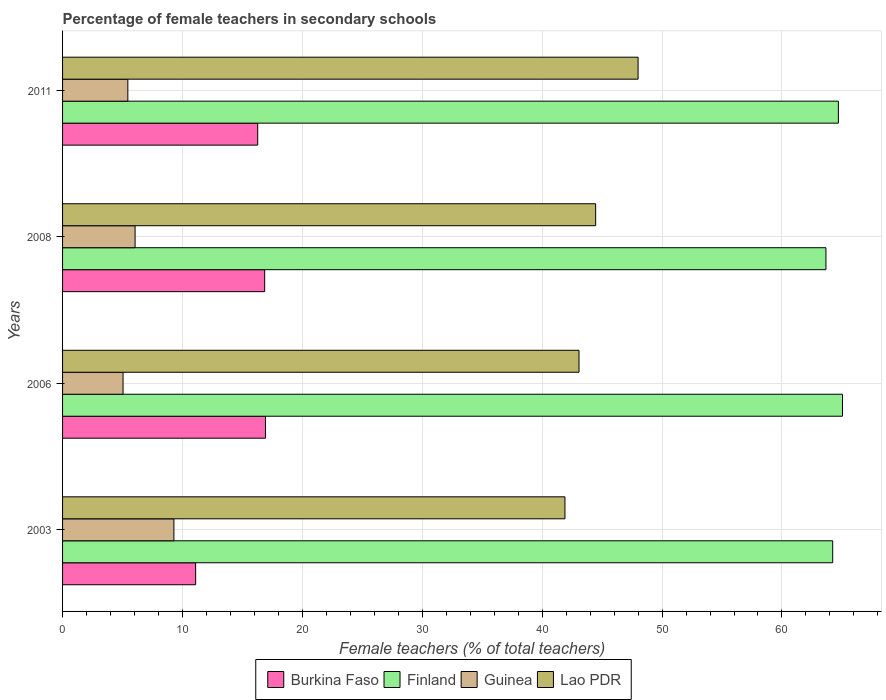How many groups of bars are there?
Your answer should be compact. 4. Are the number of bars per tick equal to the number of legend labels?
Offer a very short reply. Yes. How many bars are there on the 3rd tick from the top?
Offer a very short reply. 4. What is the percentage of female teachers in Burkina Faso in 2006?
Offer a terse response. 16.92. Across all years, what is the maximum percentage of female teachers in Burkina Faso?
Give a very brief answer. 16.92. Across all years, what is the minimum percentage of female teachers in Burkina Faso?
Your response must be concise. 11.1. In which year was the percentage of female teachers in Lao PDR maximum?
Offer a terse response. 2011. What is the total percentage of female teachers in Finland in the graph?
Give a very brief answer. 257.65. What is the difference between the percentage of female teachers in Guinea in 2008 and that in 2011?
Ensure brevity in your answer.  0.6. What is the difference between the percentage of female teachers in Burkina Faso in 2011 and the percentage of female teachers in Lao PDR in 2003?
Your response must be concise. -25.63. What is the average percentage of female teachers in Lao PDR per year?
Keep it short and to the point. 44.36. In the year 2003, what is the difference between the percentage of female teachers in Lao PDR and percentage of female teachers in Guinea?
Give a very brief answer. 32.61. What is the ratio of the percentage of female teachers in Lao PDR in 2006 to that in 2011?
Keep it short and to the point. 0.9. Is the percentage of female teachers in Burkina Faso in 2006 less than that in 2008?
Offer a very short reply. No. Is the difference between the percentage of female teachers in Lao PDR in 2003 and 2008 greater than the difference between the percentage of female teachers in Guinea in 2003 and 2008?
Give a very brief answer. No. What is the difference between the highest and the second highest percentage of female teachers in Guinea?
Ensure brevity in your answer.  3.24. What is the difference between the highest and the lowest percentage of female teachers in Finland?
Ensure brevity in your answer.  1.38. In how many years, is the percentage of female teachers in Finland greater than the average percentage of female teachers in Finland taken over all years?
Ensure brevity in your answer.  2. Is the sum of the percentage of female teachers in Finland in 2003 and 2008 greater than the maximum percentage of female teachers in Guinea across all years?
Provide a succinct answer. Yes. Is it the case that in every year, the sum of the percentage of female teachers in Guinea and percentage of female teachers in Burkina Faso is greater than the sum of percentage of female teachers in Lao PDR and percentage of female teachers in Finland?
Your response must be concise. Yes. What does the 2nd bar from the top in 2011 represents?
Ensure brevity in your answer.  Guinea. What does the 1st bar from the bottom in 2006 represents?
Provide a succinct answer. Burkina Faso. Is it the case that in every year, the sum of the percentage of female teachers in Burkina Faso and percentage of female teachers in Guinea is greater than the percentage of female teachers in Lao PDR?
Ensure brevity in your answer.  No. How many bars are there?
Give a very brief answer. 16. Are all the bars in the graph horizontal?
Keep it short and to the point. Yes. How many years are there in the graph?
Offer a terse response. 4. Are the values on the major ticks of X-axis written in scientific E-notation?
Provide a succinct answer. No. Does the graph contain any zero values?
Your response must be concise. No. Does the graph contain grids?
Keep it short and to the point. Yes. Where does the legend appear in the graph?
Offer a very short reply. Bottom center. What is the title of the graph?
Ensure brevity in your answer.  Percentage of female teachers in secondary schools. What is the label or title of the X-axis?
Provide a short and direct response. Female teachers (% of total teachers). What is the label or title of the Y-axis?
Keep it short and to the point. Years. What is the Female teachers (% of total teachers) in Burkina Faso in 2003?
Offer a very short reply. 11.1. What is the Female teachers (% of total teachers) of Finland in 2003?
Ensure brevity in your answer.  64.23. What is the Female teachers (% of total teachers) in Guinea in 2003?
Give a very brief answer. 9.29. What is the Female teachers (% of total teachers) in Lao PDR in 2003?
Provide a succinct answer. 41.9. What is the Female teachers (% of total teachers) in Burkina Faso in 2006?
Give a very brief answer. 16.92. What is the Female teachers (% of total teachers) in Finland in 2006?
Keep it short and to the point. 65.05. What is the Female teachers (% of total teachers) in Guinea in 2006?
Your answer should be compact. 5.05. What is the Female teachers (% of total teachers) of Lao PDR in 2006?
Keep it short and to the point. 43.07. What is the Female teachers (% of total teachers) of Burkina Faso in 2008?
Give a very brief answer. 16.86. What is the Female teachers (% of total teachers) in Finland in 2008?
Provide a succinct answer. 63.67. What is the Female teachers (% of total teachers) of Guinea in 2008?
Offer a terse response. 6.05. What is the Female teachers (% of total teachers) in Lao PDR in 2008?
Ensure brevity in your answer.  44.46. What is the Female teachers (% of total teachers) of Burkina Faso in 2011?
Provide a succinct answer. 16.27. What is the Female teachers (% of total teachers) in Finland in 2011?
Make the answer very short. 64.7. What is the Female teachers (% of total teachers) in Guinea in 2011?
Provide a succinct answer. 5.44. What is the Female teachers (% of total teachers) in Lao PDR in 2011?
Your response must be concise. 48. Across all years, what is the maximum Female teachers (% of total teachers) of Burkina Faso?
Make the answer very short. 16.92. Across all years, what is the maximum Female teachers (% of total teachers) in Finland?
Provide a succinct answer. 65.05. Across all years, what is the maximum Female teachers (% of total teachers) in Guinea?
Provide a succinct answer. 9.29. Across all years, what is the maximum Female teachers (% of total teachers) of Lao PDR?
Ensure brevity in your answer.  48. Across all years, what is the minimum Female teachers (% of total teachers) of Burkina Faso?
Offer a terse response. 11.1. Across all years, what is the minimum Female teachers (% of total teachers) in Finland?
Your answer should be compact. 63.67. Across all years, what is the minimum Female teachers (% of total teachers) of Guinea?
Provide a succinct answer. 5.05. Across all years, what is the minimum Female teachers (% of total teachers) in Lao PDR?
Your answer should be compact. 41.9. What is the total Female teachers (% of total teachers) in Burkina Faso in the graph?
Your answer should be compact. 61.15. What is the total Female teachers (% of total teachers) in Finland in the graph?
Your answer should be compact. 257.65. What is the total Female teachers (% of total teachers) of Guinea in the graph?
Give a very brief answer. 25.82. What is the total Female teachers (% of total teachers) in Lao PDR in the graph?
Make the answer very short. 177.43. What is the difference between the Female teachers (% of total teachers) of Burkina Faso in 2003 and that in 2006?
Provide a succinct answer. -5.82. What is the difference between the Female teachers (% of total teachers) of Finland in 2003 and that in 2006?
Offer a very short reply. -0.82. What is the difference between the Female teachers (% of total teachers) of Guinea in 2003 and that in 2006?
Provide a succinct answer. 4.24. What is the difference between the Female teachers (% of total teachers) in Lao PDR in 2003 and that in 2006?
Ensure brevity in your answer.  -1.17. What is the difference between the Female teachers (% of total teachers) of Burkina Faso in 2003 and that in 2008?
Offer a terse response. -5.76. What is the difference between the Female teachers (% of total teachers) of Finland in 2003 and that in 2008?
Offer a very short reply. 0.56. What is the difference between the Female teachers (% of total teachers) in Guinea in 2003 and that in 2008?
Your response must be concise. 3.24. What is the difference between the Female teachers (% of total teachers) of Lao PDR in 2003 and that in 2008?
Ensure brevity in your answer.  -2.56. What is the difference between the Female teachers (% of total teachers) of Burkina Faso in 2003 and that in 2011?
Make the answer very short. -5.17. What is the difference between the Female teachers (% of total teachers) of Finland in 2003 and that in 2011?
Provide a short and direct response. -0.47. What is the difference between the Female teachers (% of total teachers) in Guinea in 2003 and that in 2011?
Your answer should be compact. 3.84. What is the difference between the Female teachers (% of total teachers) of Lao PDR in 2003 and that in 2011?
Your answer should be compact. -6.1. What is the difference between the Female teachers (% of total teachers) of Burkina Faso in 2006 and that in 2008?
Ensure brevity in your answer.  0.07. What is the difference between the Female teachers (% of total teachers) of Finland in 2006 and that in 2008?
Your response must be concise. 1.38. What is the difference between the Female teachers (% of total teachers) in Guinea in 2006 and that in 2008?
Your response must be concise. -1. What is the difference between the Female teachers (% of total teachers) in Lao PDR in 2006 and that in 2008?
Make the answer very short. -1.39. What is the difference between the Female teachers (% of total teachers) in Burkina Faso in 2006 and that in 2011?
Your answer should be very brief. 0.65. What is the difference between the Female teachers (% of total teachers) in Finland in 2006 and that in 2011?
Your answer should be compact. 0.34. What is the difference between the Female teachers (% of total teachers) in Guinea in 2006 and that in 2011?
Your response must be concise. -0.4. What is the difference between the Female teachers (% of total teachers) of Lao PDR in 2006 and that in 2011?
Your response must be concise. -4.93. What is the difference between the Female teachers (% of total teachers) of Burkina Faso in 2008 and that in 2011?
Your answer should be compact. 0.58. What is the difference between the Female teachers (% of total teachers) of Finland in 2008 and that in 2011?
Give a very brief answer. -1.04. What is the difference between the Female teachers (% of total teachers) in Guinea in 2008 and that in 2011?
Provide a short and direct response. 0.6. What is the difference between the Female teachers (% of total teachers) of Lao PDR in 2008 and that in 2011?
Provide a succinct answer. -3.54. What is the difference between the Female teachers (% of total teachers) in Burkina Faso in 2003 and the Female teachers (% of total teachers) in Finland in 2006?
Keep it short and to the point. -53.95. What is the difference between the Female teachers (% of total teachers) in Burkina Faso in 2003 and the Female teachers (% of total teachers) in Guinea in 2006?
Offer a terse response. 6.05. What is the difference between the Female teachers (% of total teachers) in Burkina Faso in 2003 and the Female teachers (% of total teachers) in Lao PDR in 2006?
Your answer should be very brief. -31.97. What is the difference between the Female teachers (% of total teachers) in Finland in 2003 and the Female teachers (% of total teachers) in Guinea in 2006?
Give a very brief answer. 59.18. What is the difference between the Female teachers (% of total teachers) of Finland in 2003 and the Female teachers (% of total teachers) of Lao PDR in 2006?
Your response must be concise. 21.16. What is the difference between the Female teachers (% of total teachers) in Guinea in 2003 and the Female teachers (% of total teachers) in Lao PDR in 2006?
Provide a short and direct response. -33.79. What is the difference between the Female teachers (% of total teachers) in Burkina Faso in 2003 and the Female teachers (% of total teachers) in Finland in 2008?
Make the answer very short. -52.57. What is the difference between the Female teachers (% of total teachers) of Burkina Faso in 2003 and the Female teachers (% of total teachers) of Guinea in 2008?
Your answer should be compact. 5.05. What is the difference between the Female teachers (% of total teachers) of Burkina Faso in 2003 and the Female teachers (% of total teachers) of Lao PDR in 2008?
Your response must be concise. -33.36. What is the difference between the Female teachers (% of total teachers) in Finland in 2003 and the Female teachers (% of total teachers) in Guinea in 2008?
Keep it short and to the point. 58.18. What is the difference between the Female teachers (% of total teachers) of Finland in 2003 and the Female teachers (% of total teachers) of Lao PDR in 2008?
Offer a terse response. 19.77. What is the difference between the Female teachers (% of total teachers) of Guinea in 2003 and the Female teachers (% of total teachers) of Lao PDR in 2008?
Your answer should be very brief. -35.18. What is the difference between the Female teachers (% of total teachers) of Burkina Faso in 2003 and the Female teachers (% of total teachers) of Finland in 2011?
Your answer should be compact. -53.61. What is the difference between the Female teachers (% of total teachers) in Burkina Faso in 2003 and the Female teachers (% of total teachers) in Guinea in 2011?
Your response must be concise. 5.65. What is the difference between the Female teachers (% of total teachers) of Burkina Faso in 2003 and the Female teachers (% of total teachers) of Lao PDR in 2011?
Ensure brevity in your answer.  -36.9. What is the difference between the Female teachers (% of total teachers) in Finland in 2003 and the Female teachers (% of total teachers) in Guinea in 2011?
Your response must be concise. 58.79. What is the difference between the Female teachers (% of total teachers) of Finland in 2003 and the Female teachers (% of total teachers) of Lao PDR in 2011?
Your response must be concise. 16.23. What is the difference between the Female teachers (% of total teachers) in Guinea in 2003 and the Female teachers (% of total teachers) in Lao PDR in 2011?
Offer a terse response. -38.71. What is the difference between the Female teachers (% of total teachers) of Burkina Faso in 2006 and the Female teachers (% of total teachers) of Finland in 2008?
Keep it short and to the point. -46.74. What is the difference between the Female teachers (% of total teachers) in Burkina Faso in 2006 and the Female teachers (% of total teachers) in Guinea in 2008?
Make the answer very short. 10.88. What is the difference between the Female teachers (% of total teachers) in Burkina Faso in 2006 and the Female teachers (% of total teachers) in Lao PDR in 2008?
Make the answer very short. -27.54. What is the difference between the Female teachers (% of total teachers) of Finland in 2006 and the Female teachers (% of total teachers) of Guinea in 2008?
Your response must be concise. 59. What is the difference between the Female teachers (% of total teachers) of Finland in 2006 and the Female teachers (% of total teachers) of Lao PDR in 2008?
Give a very brief answer. 20.59. What is the difference between the Female teachers (% of total teachers) of Guinea in 2006 and the Female teachers (% of total teachers) of Lao PDR in 2008?
Make the answer very short. -39.42. What is the difference between the Female teachers (% of total teachers) of Burkina Faso in 2006 and the Female teachers (% of total teachers) of Finland in 2011?
Offer a very short reply. -47.78. What is the difference between the Female teachers (% of total teachers) in Burkina Faso in 2006 and the Female teachers (% of total teachers) in Guinea in 2011?
Your answer should be compact. 11.48. What is the difference between the Female teachers (% of total teachers) in Burkina Faso in 2006 and the Female teachers (% of total teachers) in Lao PDR in 2011?
Provide a short and direct response. -31.08. What is the difference between the Female teachers (% of total teachers) of Finland in 2006 and the Female teachers (% of total teachers) of Guinea in 2011?
Ensure brevity in your answer.  59.6. What is the difference between the Female teachers (% of total teachers) in Finland in 2006 and the Female teachers (% of total teachers) in Lao PDR in 2011?
Offer a very short reply. 17.05. What is the difference between the Female teachers (% of total teachers) of Guinea in 2006 and the Female teachers (% of total teachers) of Lao PDR in 2011?
Give a very brief answer. -42.95. What is the difference between the Female teachers (% of total teachers) in Burkina Faso in 2008 and the Female teachers (% of total teachers) in Finland in 2011?
Offer a terse response. -47.85. What is the difference between the Female teachers (% of total teachers) in Burkina Faso in 2008 and the Female teachers (% of total teachers) in Guinea in 2011?
Your response must be concise. 11.41. What is the difference between the Female teachers (% of total teachers) in Burkina Faso in 2008 and the Female teachers (% of total teachers) in Lao PDR in 2011?
Give a very brief answer. -31.14. What is the difference between the Female teachers (% of total teachers) in Finland in 2008 and the Female teachers (% of total teachers) in Guinea in 2011?
Offer a terse response. 58.22. What is the difference between the Female teachers (% of total teachers) of Finland in 2008 and the Female teachers (% of total teachers) of Lao PDR in 2011?
Keep it short and to the point. 15.67. What is the difference between the Female teachers (% of total teachers) of Guinea in 2008 and the Female teachers (% of total teachers) of Lao PDR in 2011?
Offer a terse response. -41.95. What is the average Female teachers (% of total teachers) of Burkina Faso per year?
Make the answer very short. 15.29. What is the average Female teachers (% of total teachers) in Finland per year?
Your answer should be very brief. 64.41. What is the average Female teachers (% of total teachers) of Guinea per year?
Your answer should be compact. 6.46. What is the average Female teachers (% of total teachers) in Lao PDR per year?
Offer a terse response. 44.36. In the year 2003, what is the difference between the Female teachers (% of total teachers) of Burkina Faso and Female teachers (% of total teachers) of Finland?
Offer a terse response. -53.13. In the year 2003, what is the difference between the Female teachers (% of total teachers) of Burkina Faso and Female teachers (% of total teachers) of Guinea?
Your answer should be very brief. 1.81. In the year 2003, what is the difference between the Female teachers (% of total teachers) in Burkina Faso and Female teachers (% of total teachers) in Lao PDR?
Your answer should be very brief. -30.8. In the year 2003, what is the difference between the Female teachers (% of total teachers) in Finland and Female teachers (% of total teachers) in Guinea?
Your answer should be very brief. 54.94. In the year 2003, what is the difference between the Female teachers (% of total teachers) of Finland and Female teachers (% of total teachers) of Lao PDR?
Make the answer very short. 22.33. In the year 2003, what is the difference between the Female teachers (% of total teachers) of Guinea and Female teachers (% of total teachers) of Lao PDR?
Keep it short and to the point. -32.61. In the year 2006, what is the difference between the Female teachers (% of total teachers) in Burkina Faso and Female teachers (% of total teachers) in Finland?
Your response must be concise. -48.13. In the year 2006, what is the difference between the Female teachers (% of total teachers) of Burkina Faso and Female teachers (% of total teachers) of Guinea?
Offer a terse response. 11.88. In the year 2006, what is the difference between the Female teachers (% of total teachers) of Burkina Faso and Female teachers (% of total teachers) of Lao PDR?
Your response must be concise. -26.15. In the year 2006, what is the difference between the Female teachers (% of total teachers) in Finland and Female teachers (% of total teachers) in Guinea?
Your response must be concise. 60. In the year 2006, what is the difference between the Female teachers (% of total teachers) in Finland and Female teachers (% of total teachers) in Lao PDR?
Offer a terse response. 21.98. In the year 2006, what is the difference between the Female teachers (% of total teachers) of Guinea and Female teachers (% of total teachers) of Lao PDR?
Make the answer very short. -38.03. In the year 2008, what is the difference between the Female teachers (% of total teachers) of Burkina Faso and Female teachers (% of total teachers) of Finland?
Your answer should be compact. -46.81. In the year 2008, what is the difference between the Female teachers (% of total teachers) of Burkina Faso and Female teachers (% of total teachers) of Guinea?
Give a very brief answer. 10.81. In the year 2008, what is the difference between the Female teachers (% of total teachers) in Burkina Faso and Female teachers (% of total teachers) in Lao PDR?
Give a very brief answer. -27.6. In the year 2008, what is the difference between the Female teachers (% of total teachers) of Finland and Female teachers (% of total teachers) of Guinea?
Offer a very short reply. 57.62. In the year 2008, what is the difference between the Female teachers (% of total teachers) of Finland and Female teachers (% of total teachers) of Lao PDR?
Offer a terse response. 19.21. In the year 2008, what is the difference between the Female teachers (% of total teachers) in Guinea and Female teachers (% of total teachers) in Lao PDR?
Give a very brief answer. -38.41. In the year 2011, what is the difference between the Female teachers (% of total teachers) of Burkina Faso and Female teachers (% of total teachers) of Finland?
Provide a succinct answer. -48.43. In the year 2011, what is the difference between the Female teachers (% of total teachers) in Burkina Faso and Female teachers (% of total teachers) in Guinea?
Your answer should be very brief. 10.83. In the year 2011, what is the difference between the Female teachers (% of total teachers) in Burkina Faso and Female teachers (% of total teachers) in Lao PDR?
Provide a short and direct response. -31.73. In the year 2011, what is the difference between the Female teachers (% of total teachers) of Finland and Female teachers (% of total teachers) of Guinea?
Make the answer very short. 59.26. In the year 2011, what is the difference between the Female teachers (% of total teachers) of Finland and Female teachers (% of total teachers) of Lao PDR?
Ensure brevity in your answer.  16.7. In the year 2011, what is the difference between the Female teachers (% of total teachers) in Guinea and Female teachers (% of total teachers) in Lao PDR?
Provide a succinct answer. -42.56. What is the ratio of the Female teachers (% of total teachers) of Burkina Faso in 2003 to that in 2006?
Ensure brevity in your answer.  0.66. What is the ratio of the Female teachers (% of total teachers) in Finland in 2003 to that in 2006?
Offer a terse response. 0.99. What is the ratio of the Female teachers (% of total teachers) of Guinea in 2003 to that in 2006?
Make the answer very short. 1.84. What is the ratio of the Female teachers (% of total teachers) in Lao PDR in 2003 to that in 2006?
Your response must be concise. 0.97. What is the ratio of the Female teachers (% of total teachers) of Burkina Faso in 2003 to that in 2008?
Your answer should be compact. 0.66. What is the ratio of the Female teachers (% of total teachers) in Finland in 2003 to that in 2008?
Provide a short and direct response. 1.01. What is the ratio of the Female teachers (% of total teachers) of Guinea in 2003 to that in 2008?
Ensure brevity in your answer.  1.54. What is the ratio of the Female teachers (% of total teachers) of Lao PDR in 2003 to that in 2008?
Make the answer very short. 0.94. What is the ratio of the Female teachers (% of total teachers) in Burkina Faso in 2003 to that in 2011?
Provide a short and direct response. 0.68. What is the ratio of the Female teachers (% of total teachers) in Guinea in 2003 to that in 2011?
Offer a very short reply. 1.71. What is the ratio of the Female teachers (% of total teachers) in Lao PDR in 2003 to that in 2011?
Keep it short and to the point. 0.87. What is the ratio of the Female teachers (% of total teachers) in Burkina Faso in 2006 to that in 2008?
Provide a succinct answer. 1. What is the ratio of the Female teachers (% of total teachers) in Finland in 2006 to that in 2008?
Your answer should be very brief. 1.02. What is the ratio of the Female teachers (% of total teachers) in Guinea in 2006 to that in 2008?
Make the answer very short. 0.83. What is the ratio of the Female teachers (% of total teachers) in Lao PDR in 2006 to that in 2008?
Provide a short and direct response. 0.97. What is the ratio of the Female teachers (% of total teachers) of Burkina Faso in 2006 to that in 2011?
Your answer should be very brief. 1.04. What is the ratio of the Female teachers (% of total teachers) in Guinea in 2006 to that in 2011?
Your answer should be very brief. 0.93. What is the ratio of the Female teachers (% of total teachers) of Lao PDR in 2006 to that in 2011?
Ensure brevity in your answer.  0.9. What is the ratio of the Female teachers (% of total teachers) in Burkina Faso in 2008 to that in 2011?
Your answer should be compact. 1.04. What is the ratio of the Female teachers (% of total teachers) of Guinea in 2008 to that in 2011?
Make the answer very short. 1.11. What is the ratio of the Female teachers (% of total teachers) in Lao PDR in 2008 to that in 2011?
Keep it short and to the point. 0.93. What is the difference between the highest and the second highest Female teachers (% of total teachers) in Burkina Faso?
Provide a short and direct response. 0.07. What is the difference between the highest and the second highest Female teachers (% of total teachers) in Finland?
Ensure brevity in your answer.  0.34. What is the difference between the highest and the second highest Female teachers (% of total teachers) in Guinea?
Ensure brevity in your answer.  3.24. What is the difference between the highest and the second highest Female teachers (% of total teachers) of Lao PDR?
Keep it short and to the point. 3.54. What is the difference between the highest and the lowest Female teachers (% of total teachers) of Burkina Faso?
Offer a very short reply. 5.82. What is the difference between the highest and the lowest Female teachers (% of total teachers) in Finland?
Make the answer very short. 1.38. What is the difference between the highest and the lowest Female teachers (% of total teachers) of Guinea?
Your response must be concise. 4.24. What is the difference between the highest and the lowest Female teachers (% of total teachers) of Lao PDR?
Give a very brief answer. 6.1. 